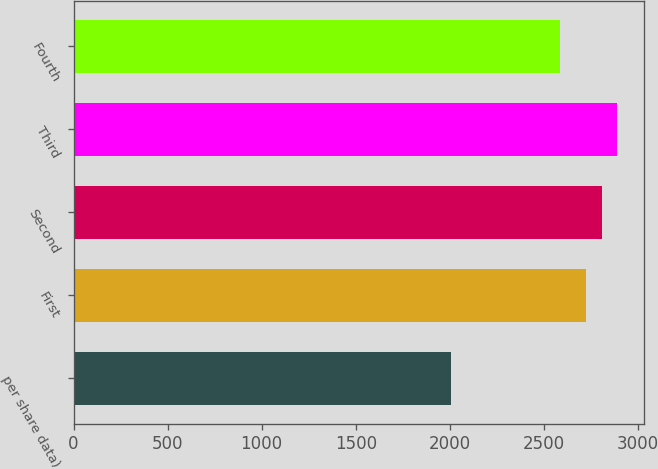Convert chart. <chart><loc_0><loc_0><loc_500><loc_500><bar_chart><fcel>per share data)<fcel>First<fcel>Second<fcel>Third<fcel>Fourth<nl><fcel>2006<fcel>2726.5<fcel>2808.14<fcel>2889.78<fcel>2583.9<nl></chart> 